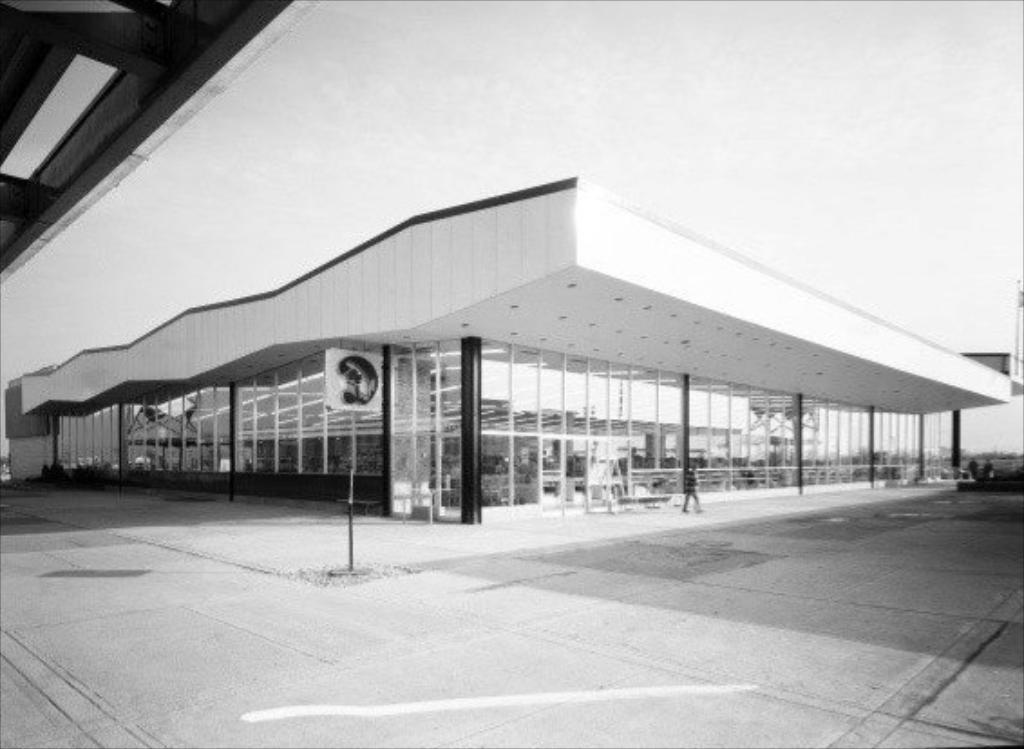What type of structure is present in the image? There is a building in the image. What can be seen in the background of the image? The sky is visible in the background of the image. What type of powder is being used on the face of the person in the image? There is no person or powder present in the image; it only features a building and the sky. 